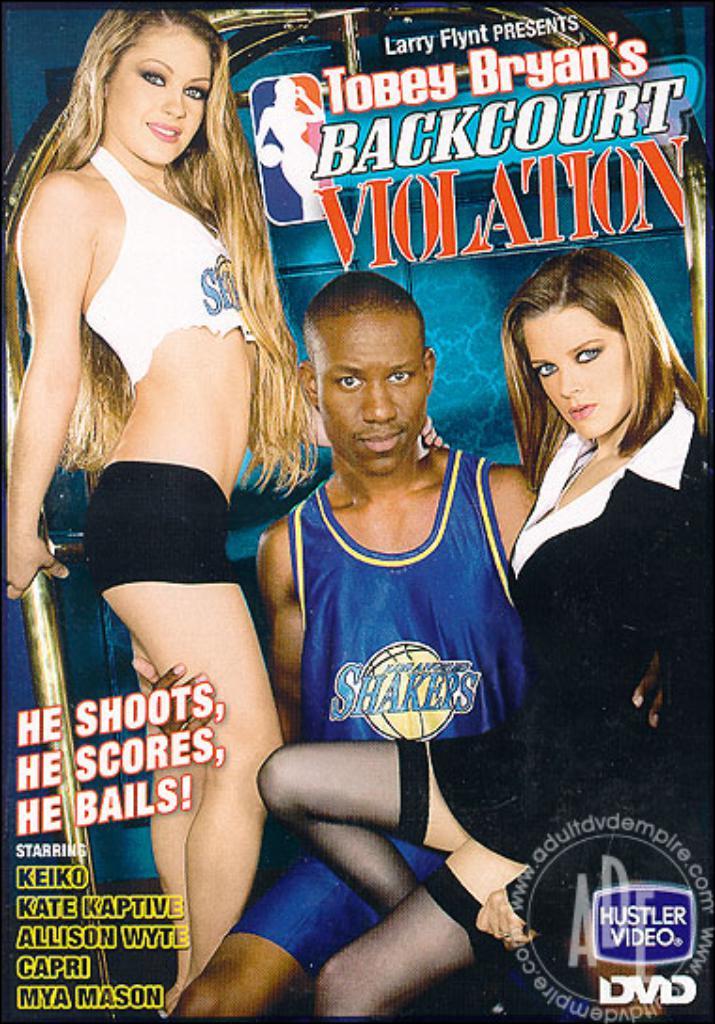Is the movie x-rated ?
Keep it short and to the point. Yes. What is the title of this film?
Offer a terse response. Tobey bryan's backcourt violation. 